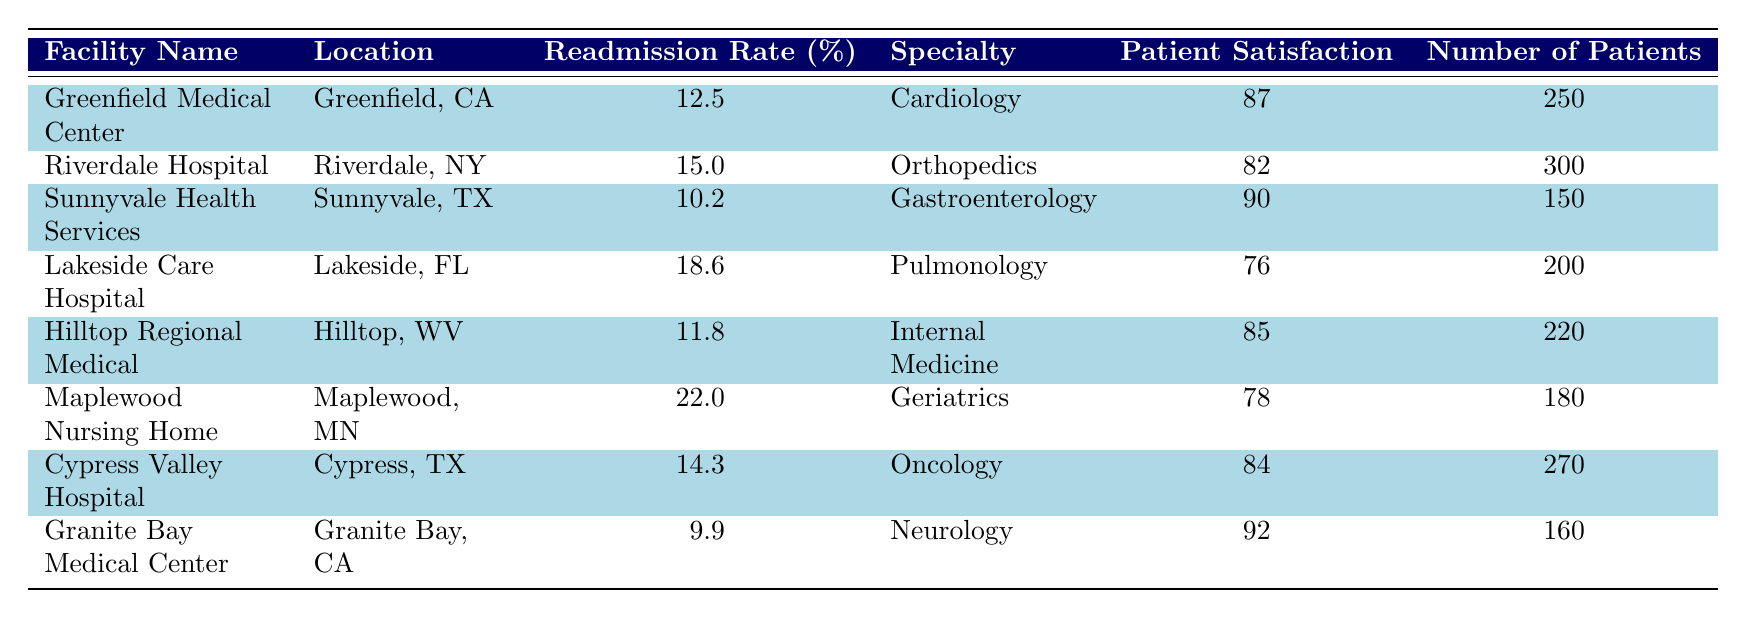What is the readmission rate for Sunnyvale Health Services? The table shows that Sunnyvale Health Services has a readmission rate listed as 10.2%.
Answer: 10.2% Which facility has the highest patient satisfaction score? By reviewing the "Patient Satisfaction" column, Granite Bay Medical Center has the highest score at 92.
Answer: 92 What is the average readmission rate across all facilities? To calculate the average, sum all the readmission rates (12.5 + 15.0 + 10.2 + 18.6 + 11.8 + 22.0 + 14.3 + 9.9) = 114.3. Dividing this by the number of facilities (8) gives the average readmission rate, which is 14.29%.
Answer: 14.3% Does Lakeside Care Hospital have a readmission rate higher than 15%? The readmission rate for Lakeside Care Hospital is 18.6%, which is indeed higher than 15%.
Answer: Yes What is the difference in patient satisfaction scores between Riverdale Hospital and Hilltop Regional Medical? The patient satisfaction score for Riverdale Hospital is 82 and for Hilltop Regional Medical is 85. The difference is 85 - 82 = 3.
Answer: 3 Which specialty is associated with the lowest readmission rate among the listed facilities? The lowest readmission rate is at Sunnyvale Health Services with a rate of 10.2%, which is associated with the specialty of Gastroenterology.
Answer: Gastroenterology What is the total number of patients across all facilities? Adding the number of patients from each facility (250 + 300 + 150 + 200 + 220 + 180 + 270 + 160) gives a total of 1,730 patients.
Answer: 1730 Does Maplewood Nursing Home have the highest readmission rate among the listed facilities? Upon checking the readmission rates, Maplewood Nursing Home has a rate of 22.0%, which is higher than all others in the table.
Answer: Yes 